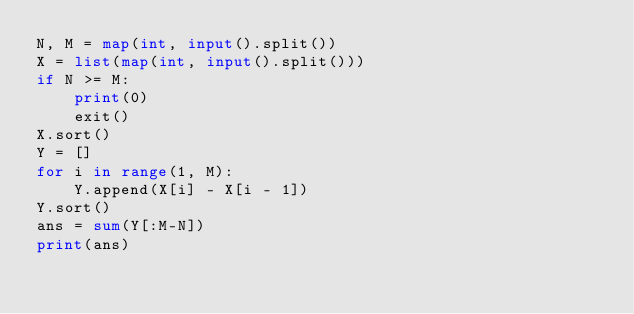<code> <loc_0><loc_0><loc_500><loc_500><_Python_>N, M = map(int, input().split())
X = list(map(int, input().split()))
if N >= M:
    print(0)
    exit()
X.sort()
Y = []
for i in range(1, M):
    Y.append(X[i] - X[i - 1])
Y.sort()
ans = sum(Y[:M-N])
print(ans)
</code> 